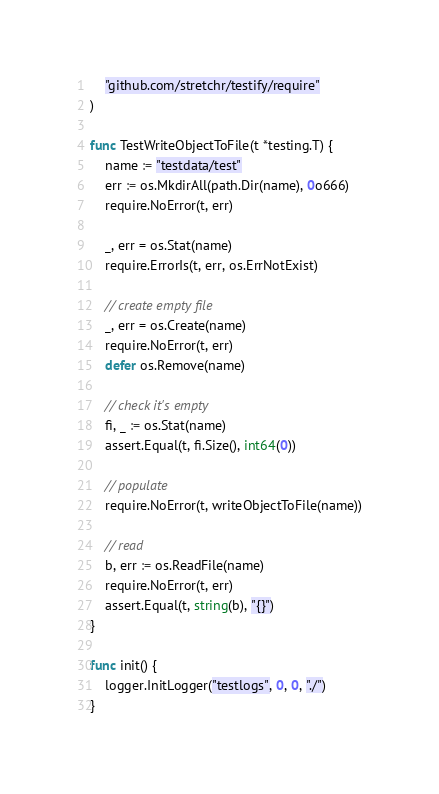<code> <loc_0><loc_0><loc_500><loc_500><_Go_>	"github.com/stretchr/testify/require"
)

func TestWriteObjectToFile(t *testing.T) {
	name := "testdata/test"
	err := os.MkdirAll(path.Dir(name), 0o666)
	require.NoError(t, err)

	_, err = os.Stat(name)
	require.ErrorIs(t, err, os.ErrNotExist)

	// create empty file
	_, err = os.Create(name)
	require.NoError(t, err)
	defer os.Remove(name)

	// check it's empty
	fi, _ := os.Stat(name)
	assert.Equal(t, fi.Size(), int64(0))

	// populate
	require.NoError(t, writeObjectToFile(name))

	// read
	b, err := os.ReadFile(name)
	require.NoError(t, err)
	assert.Equal(t, string(b), "{}")
}

func init() {
	logger.InitLogger("testlogs", 0, 0, "./")
}
</code> 